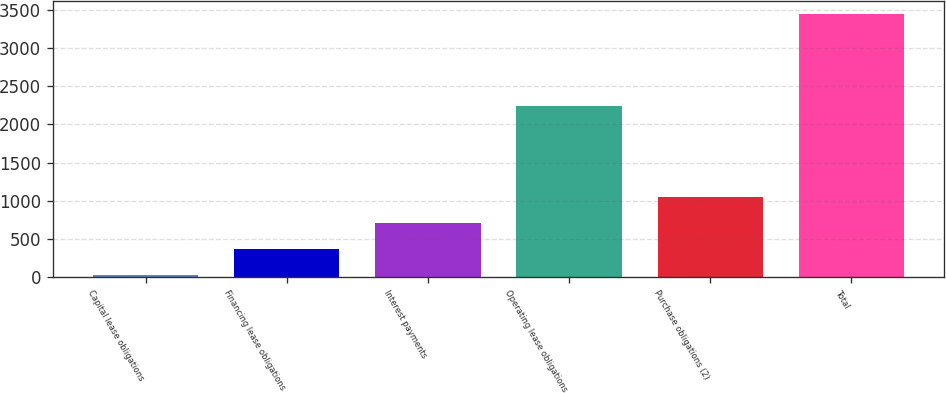Convert chart. <chart><loc_0><loc_0><loc_500><loc_500><bar_chart><fcel>Capital lease obligations<fcel>Financing lease obligations<fcel>Interest payments<fcel>Operating lease obligations<fcel>Purchase obligations (2)<fcel>Total<nl><fcel>27<fcel>369.1<fcel>711.2<fcel>2245<fcel>1053.3<fcel>3448<nl></chart> 